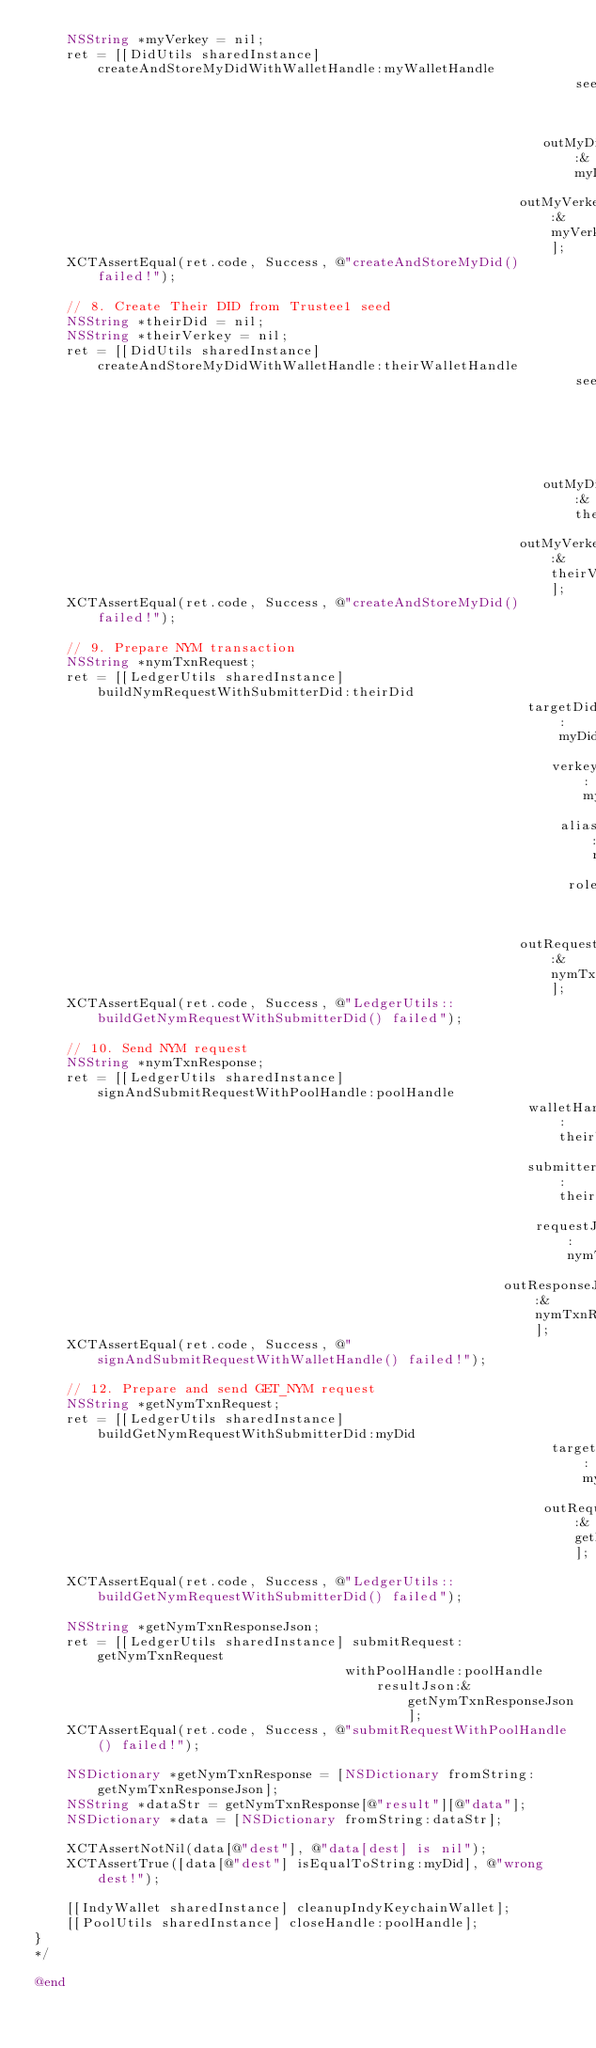<code> <loc_0><loc_0><loc_500><loc_500><_ObjectiveC_>    NSString *myVerkey = nil;
    ret = [[DidUtils sharedInstance] createAndStoreMyDidWithWalletHandle:myWalletHandle
                                                                    seed:nil
                                                                outMyDid:&myDid
                                                             outMyVerkey:&myVerkey];
    XCTAssertEqual(ret.code, Success, @"createAndStoreMyDid() failed!");

    // 8. Create Their DID from Trustee1 seed
    NSString *theirDid = nil;
    NSString *theirVerkey = nil;
    ret = [[DidUtils sharedInstance] createAndStoreMyDidWithWalletHandle:theirWalletHandle
                                                                    seed:[TestUtils trusteeSeed]
                                                                outMyDid:&theirDid
                                                             outMyVerkey:&theirVerkey];
    XCTAssertEqual(ret.code, Success, @"createAndStoreMyDid() failed!");

    // 9. Prepare NYM transaction
    NSString *nymTxnRequest;
    ret = [[LedgerUtils sharedInstance] buildNymRequestWithSubmitterDid:theirDid
                                                              targetDid:myDid
                                                                 verkey:myVerkey
                                                                  alias:nil
                                                                   role:nil
                                                             outRequest:&nymTxnRequest];
    XCTAssertEqual(ret.code, Success, @"LedgerUtils::buildGetNymRequestWithSubmitterDid() failed");

    // 10. Send NYM request
    NSString *nymTxnResponse;
    ret = [[LedgerUtils sharedInstance] signAndSubmitRequestWithPoolHandle:poolHandle
                                                              walletHandle:theirWalletHandle
                                                              submitterDid:theirDid
                                                               requestJson:nymTxnRequest
                                                           outResponseJson:&nymTxnResponse];
    XCTAssertEqual(ret.code, Success, @"signAndSubmitRequestWithWalletHandle() failed!");

    // 12. Prepare and send GET_NYM request
    NSString *getNymTxnRequest;
    ret = [[LedgerUtils sharedInstance] buildGetNymRequestWithSubmitterDid:myDid
                                                                 targetDid:myDid
                                                                outRequest:&getNymTxnRequest];
    XCTAssertEqual(ret.code, Success, @"LedgerUtils::buildGetNymRequestWithSubmitterDid() failed");

    NSString *getNymTxnResponseJson;
    ret = [[LedgerUtils sharedInstance] submitRequest:getNymTxnRequest
                                       withPoolHandle:poolHandle
                                           resultJson:&getNymTxnResponseJson];
    XCTAssertEqual(ret.code, Success, @"submitRequestWithPoolHandle() failed!");

    NSDictionary *getNymTxnResponse = [NSDictionary fromString:getNymTxnResponseJson];
    NSString *dataStr = getNymTxnResponse[@"result"][@"data"];
    NSDictionary *data = [NSDictionary fromString:dataStr];

    XCTAssertNotNil(data[@"dest"], @"data[dest] is nil");
    XCTAssertTrue([data[@"dest"] isEqualToString:myDid], @"wrong dest!");

    [[IndyWallet sharedInstance] cleanupIndyKeychainWallet];
    [[PoolUtils sharedInstance] closeHandle:poolHandle];
}
*/

@end
</code> 